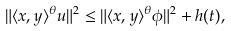<formula> <loc_0><loc_0><loc_500><loc_500>\| \langle x , y \rangle ^ { \theta } u \| ^ { 2 } \leq \| \langle x , y \rangle ^ { \theta } \phi \| ^ { 2 } + h ( t ) ,</formula> 